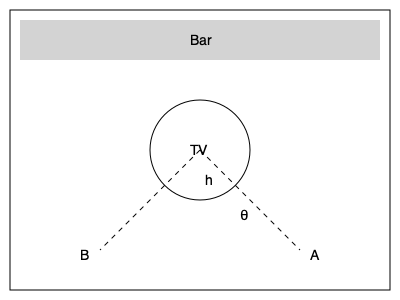As a sports bar owner, you want to optimize the placement of TV screens for maximum viewership. Using 3D modeling of your bar space, you determine that the optimal viewing angle θ for your patrons is 30°. If the center of a 50-inch TV screen is mounted at a height h = 2.5 meters above the floor, what is the maximum distance (in meters) from directly below the TV that a patron can stand while maintaining the optimal viewing angle? Round your answer to two decimal places. To solve this problem, we'll use trigonometry and the given information:

1. The optimal viewing angle θ = 30°
2. The height of the TV center h = 2.5 meters

We can visualize this as a right triangle, where:
- The height (h) is the opposite side
- The distance from below the TV to the patron is the adjacent side
- The line from the TV to the patron's eyes forms the hypotenuse

We want to find the adjacent side, which we'll call d.

Using the tangent function:

$$ \tan θ = \frac{\text{opposite}}{\text{adjacent}} = \frac{h}{d} $$

Rearranging this equation:

$$ d = \frac{h}{\tan θ} $$

Plugging in our values:

$$ d = \frac{2.5}{\tan 30°} $$

To calculate this:

1. $\tan 30° ≈ 0.577350269$
2. $d = 2.5 \div 0.577350269$
3. $d ≈ 4.330127019$ meters

Rounding to two decimal places:

$d ≈ 4.33$ meters

This means that a patron can stand up to 4.33 meters away from the point directly below the TV while maintaining the optimal 30° viewing angle.
Answer: 4.33 meters 